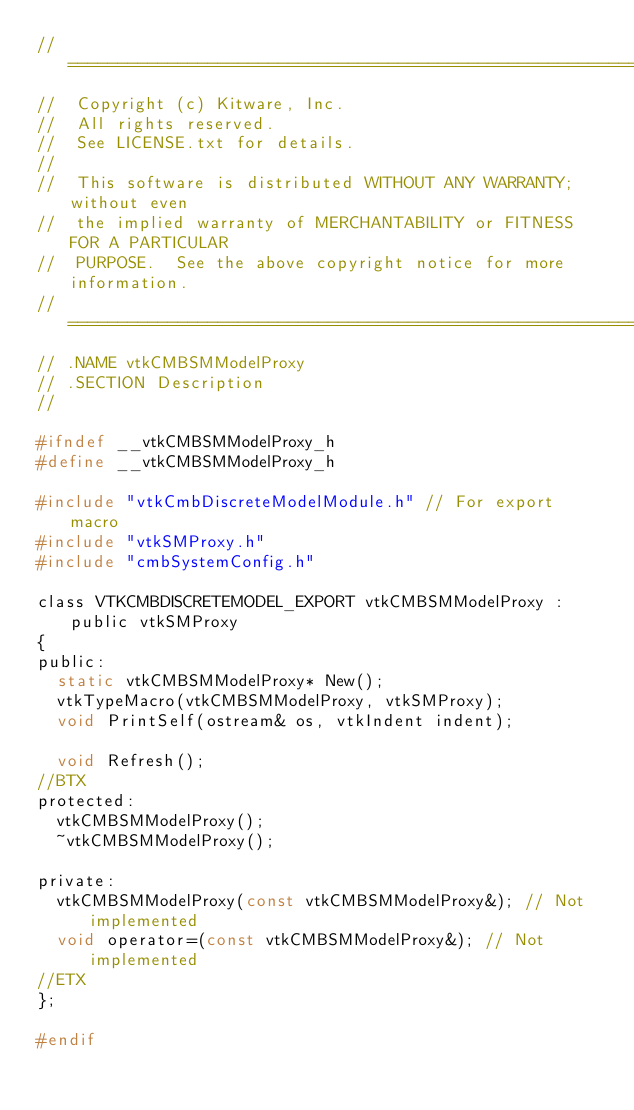Convert code to text. <code><loc_0><loc_0><loc_500><loc_500><_C_>//=========================================================================
//  Copyright (c) Kitware, Inc.
//  All rights reserved.
//  See LICENSE.txt for details.
//
//  This software is distributed WITHOUT ANY WARRANTY; without even
//  the implied warranty of MERCHANTABILITY or FITNESS FOR A PARTICULAR
//  PURPOSE.  See the above copyright notice for more information.
//=========================================================================
// .NAME vtkCMBSMModelProxy
// .SECTION Description
//

#ifndef __vtkCMBSMModelProxy_h
#define __vtkCMBSMModelProxy_h

#include "vtkCmbDiscreteModelModule.h" // For export macro
#include "vtkSMProxy.h"
#include "cmbSystemConfig.h"

class VTKCMBDISCRETEMODEL_EXPORT vtkCMBSMModelProxy : public vtkSMProxy
{
public:
  static vtkCMBSMModelProxy* New();
  vtkTypeMacro(vtkCMBSMModelProxy, vtkSMProxy);
  void PrintSelf(ostream& os, vtkIndent indent);

  void Refresh();
//BTX
protected:
  vtkCMBSMModelProxy();
  ~vtkCMBSMModelProxy();

private:
  vtkCMBSMModelProxy(const vtkCMBSMModelProxy&); // Not implemented
  void operator=(const vtkCMBSMModelProxy&); // Not implemented
//ETX
};

#endif

</code> 